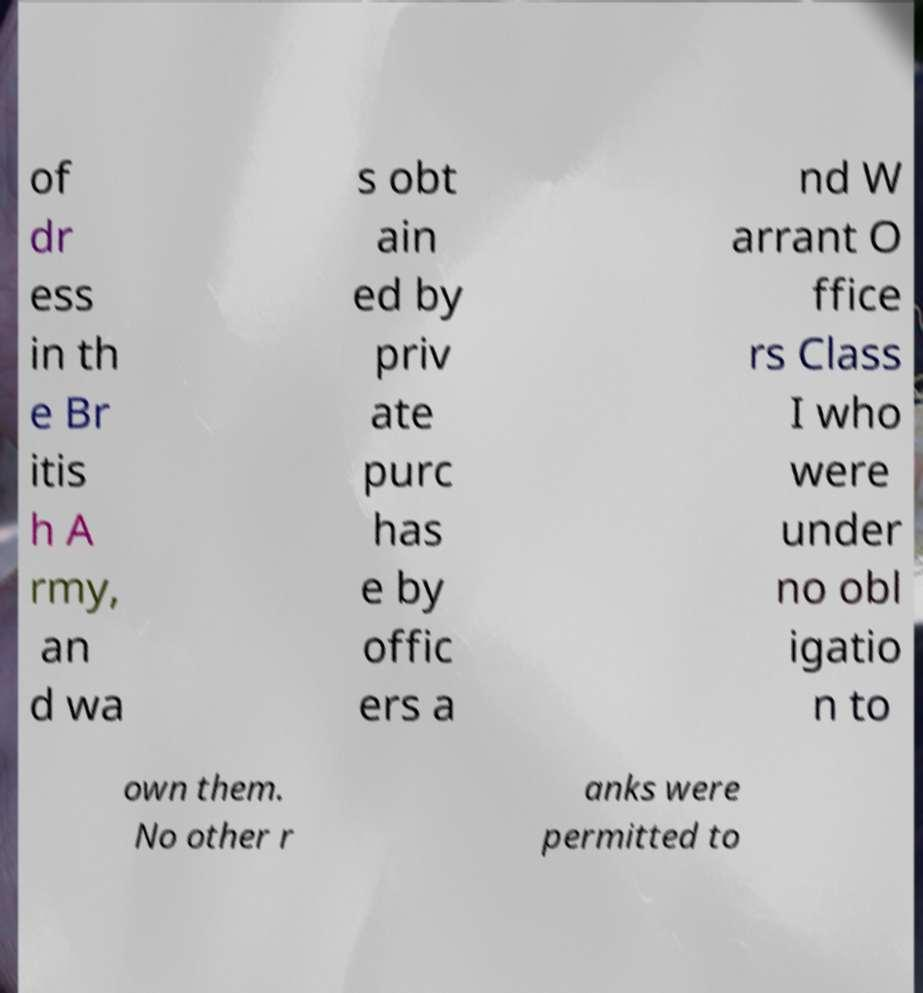I need the written content from this picture converted into text. Can you do that? of dr ess in th e Br itis h A rmy, an d wa s obt ain ed by priv ate purc has e by offic ers a nd W arrant O ffice rs Class I who were under no obl igatio n to own them. No other r anks were permitted to 